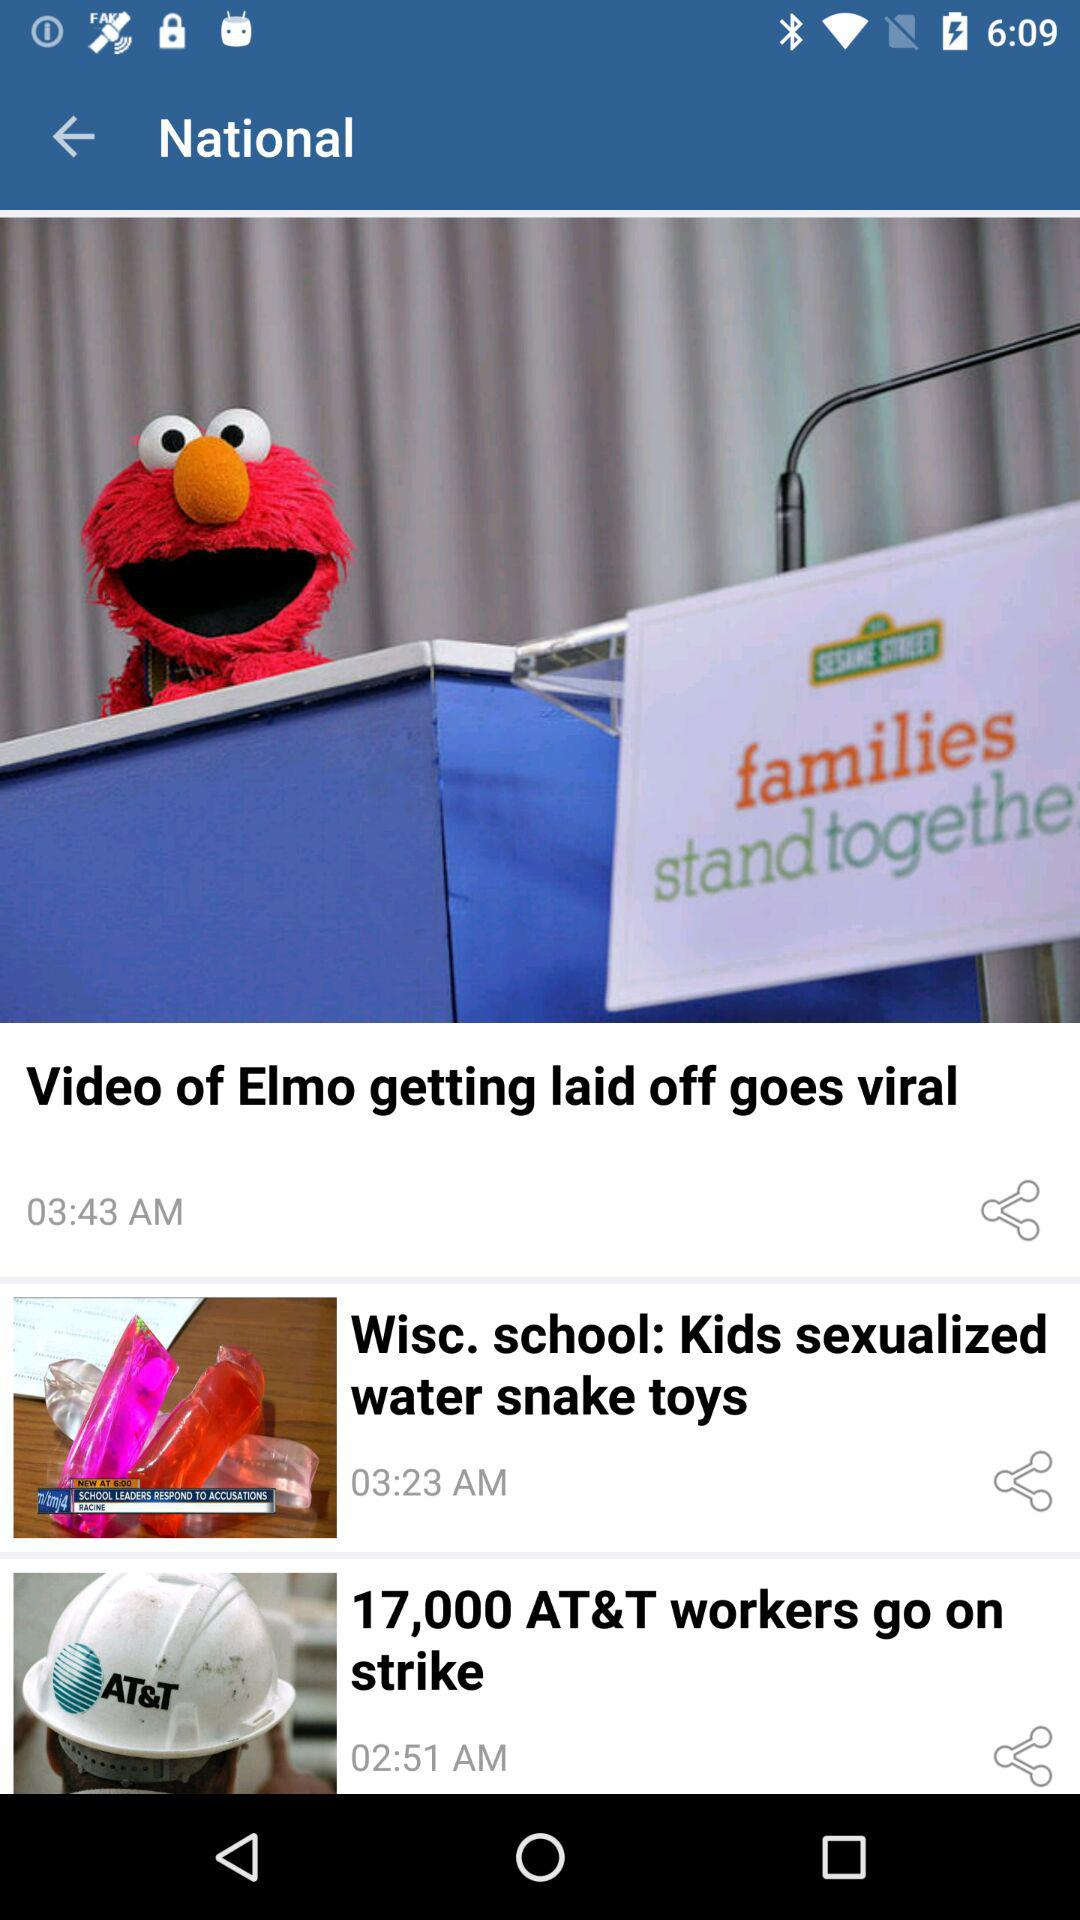What is the time of "Wisc. school: Kids sexualized water snake toys"? The time is 03:23 a.m. 